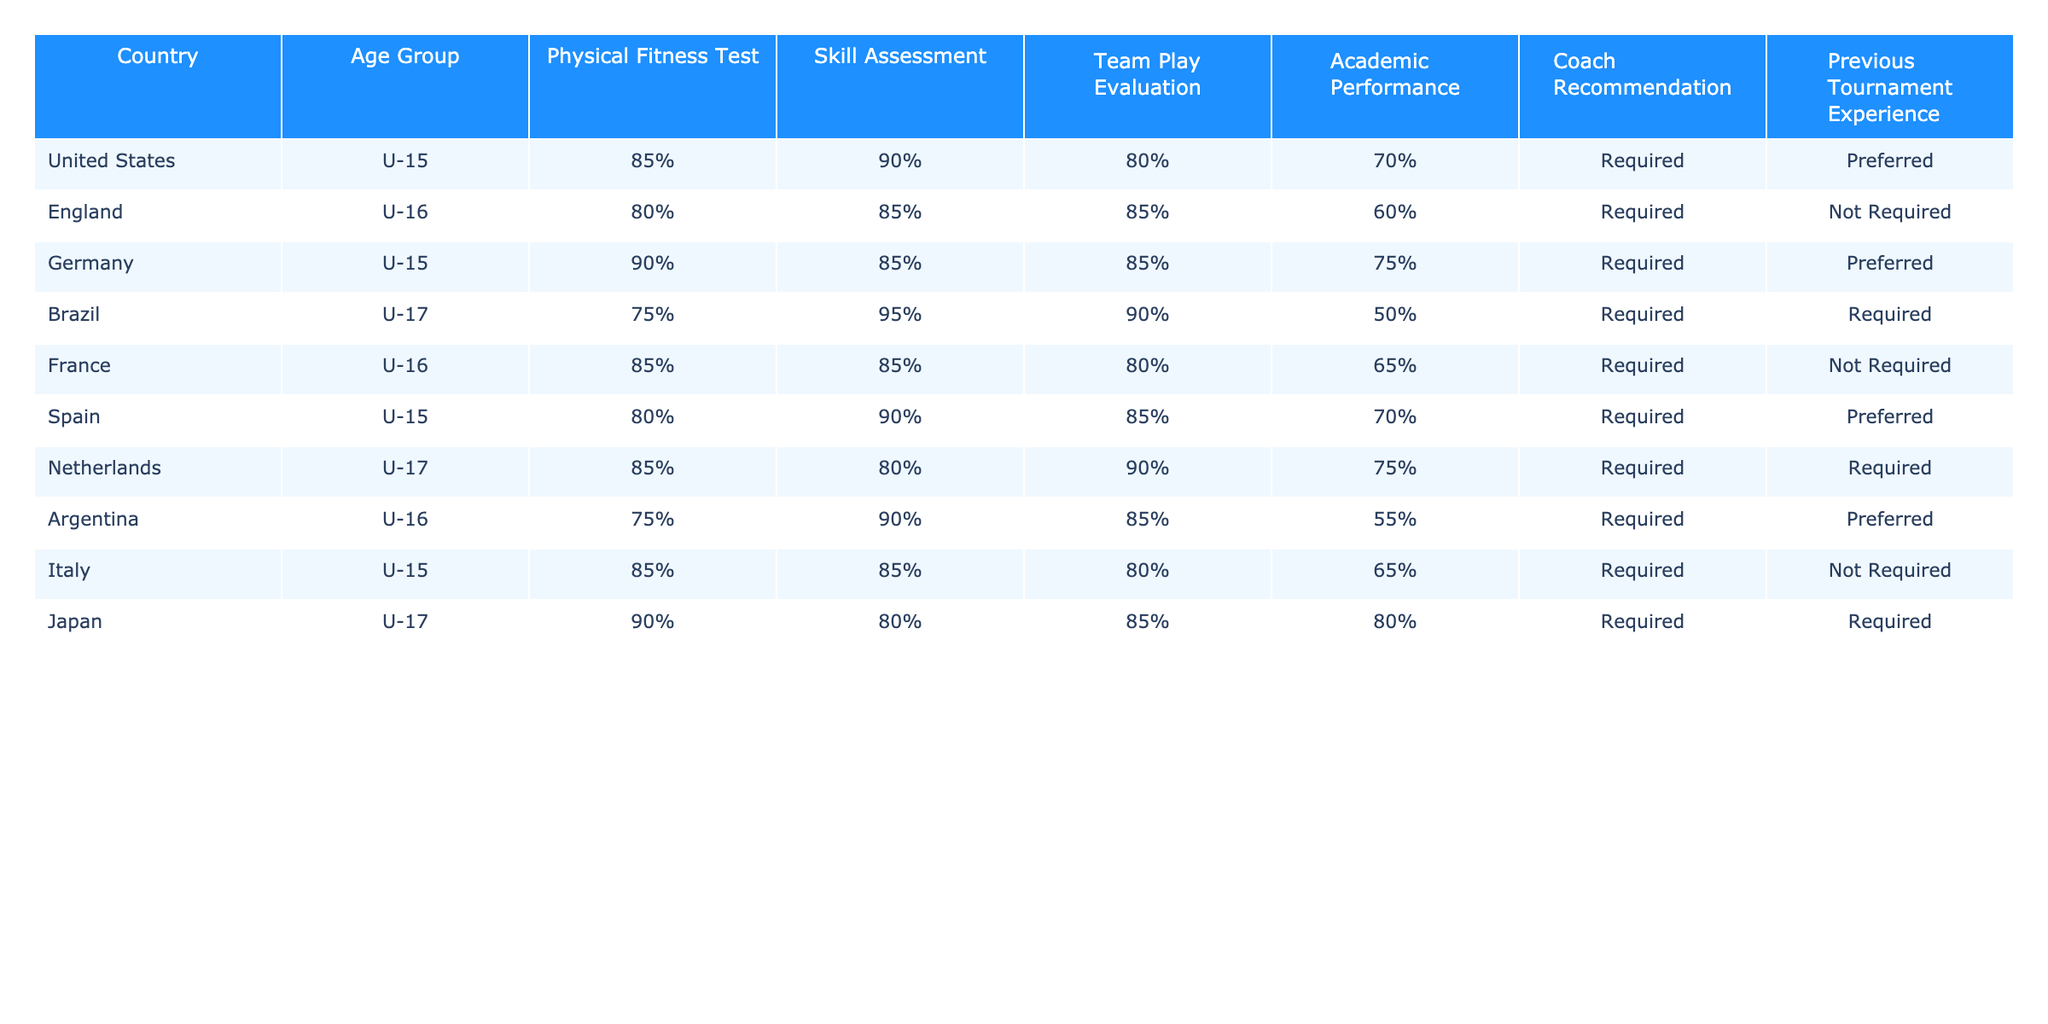What is the highest percentage in the Physical Fitness Test among the teams? The Physical Fitness Test percentages are: United States (85%), England (80%), Germany (90%), Brazil (75%), France (85%), Spain (80%), Netherlands (85%), Argentina (75%), Italy (85%), Japan (90%). The highest percentage is 90%, from Germany and Japan.
Answer: 90% Which country has the lowest score in Academic Performance? The Academic Performance scores are: United States (70%), England (60%), Germany (75%), Brazil (50%), France (65%), Spain (70%), Netherlands (75%), Argentina (55%), Italy (65%), Japan (80%). The lowest score is 50% from Brazil.
Answer: Brazil Do all teams require a Coach Recommendation? Looking at the 'Coach Recommendation' column, Brazil and the Netherlands are the only teams that have 'Required' while all other teams have 'Required' also. Thus, all teams do require a Coach Recommendation.
Answer: Yes Which team has the best Skill Assessment score and what is it? The Skill Assessment scores are: United States (90%), England (85%), Germany (85%), Brazil (95%), France (85%), Spain (90%), Netherlands (80%), Argentina (90%), Italy (85%), Japan (80%). The best score is 95%, from Brazil.
Answer: Brazil, 95% Calculate the average score of Team Play Evaluation for the U-15 teams. The Team Play Evaluation scores for U-15 teams are: United States (80%), Germany (85%), Spain (85%), and Italy (80%). The average is calculated as (80 + 85 + 85 + 80) / 4 = 82.5.
Answer: 82.5 Which age group has the highest average score in Physical Fitness Test? The Physical Fitness Test scores by age group are: U-15 (85%, 80%, 90%, 85%), U-16 (80%, 85%, 85%), and U-17 (75%, 85%, 90%). The averages are: U-15 = (85 + 90 + 80 + 85) / 4 = 85, U-16 = (80 + 85 + 85) / 3 = 83.33, U-17 = (75 + 85 + 90) / 3 = 83.33. The highest average is 85% for U-15.
Answer: U-15 Is there any team with no previous tournament experience requirement? Referring to the 'Previous Tournament Experience' column, the teams 'England' and 'Italy' have 'Not Required'. Thus, there are teams with no previous tournament experience requirement.
Answer: Yes What is the total count of teams that scored above 80% in Team Play Evaluation? The Team Play Evaluation scores are: United States (80%), Germany (85%), Brazil (90%), Spain (85%), and Italy (80%). The teams scoring above 80% are Germany, Brazil, and Spain, totaling 3 teams.
Answer: 3 